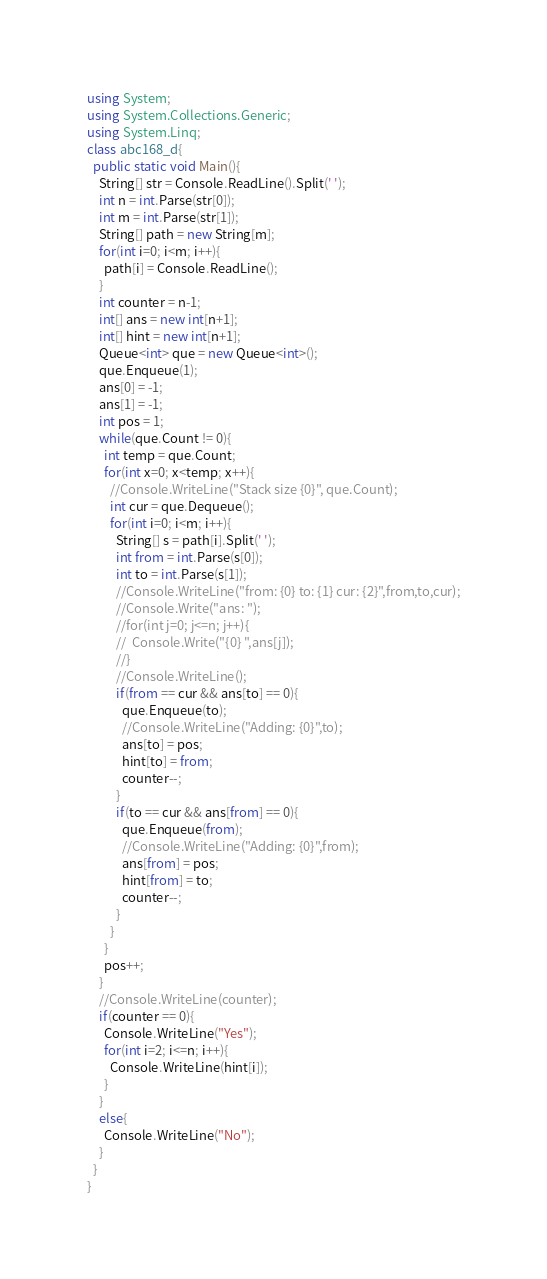<code> <loc_0><loc_0><loc_500><loc_500><_C#_>using System;
using System.Collections.Generic;
using System.Linq;
class abc168_d{
  public static void Main(){
    String[] str = Console.ReadLine().Split(' ');
    int n = int.Parse(str[0]);
    int m = int.Parse(str[1]);
    String[] path = new String[m];
    for(int i=0; i<m; i++){
      path[i] = Console.ReadLine();
    }
    int counter = n-1;
    int[] ans = new int[n+1];
    int[] hint = new int[n+1];
    Queue<int> que = new Queue<int>();
    que.Enqueue(1);
    ans[0] = -1;
    ans[1] = -1;
    int pos = 1;
    while(que.Count != 0){
      int temp = que.Count;
      for(int x=0; x<temp; x++){
        //Console.WriteLine("Stack size {0}", que.Count);
        int cur = que.Dequeue();
        for(int i=0; i<m; i++){
          String[] s = path[i].Split(' ');
          int from = int.Parse(s[0]);
          int to = int.Parse(s[1]);
          //Console.WriteLine("from: {0} to: {1} cur: {2}",from,to,cur);
          //Console.Write("ans: ");
          //for(int j=0; j<=n; j++){
          //  Console.Write("{0} ",ans[j]);
          //}
          //Console.WriteLine();
          if(from == cur && ans[to] == 0){
            que.Enqueue(to);
            //Console.WriteLine("Adding: {0}",to);
            ans[to] = pos;
            hint[to] = from;
            counter--;
          }
          if(to == cur && ans[from] == 0){
            que.Enqueue(from);
            //Console.WriteLine("Adding: {0}",from);
            ans[from] = pos;
            hint[from] = to;
            counter--;
          }
        }
      }
      pos++;
    }
    //Console.WriteLine(counter);
    if(counter == 0){
      Console.WriteLine("Yes");
      for(int i=2; i<=n; i++){
        Console.WriteLine(hint[i]);
      }
    }
    else{
      Console.WriteLine("No");
    }
  }
}
</code> 